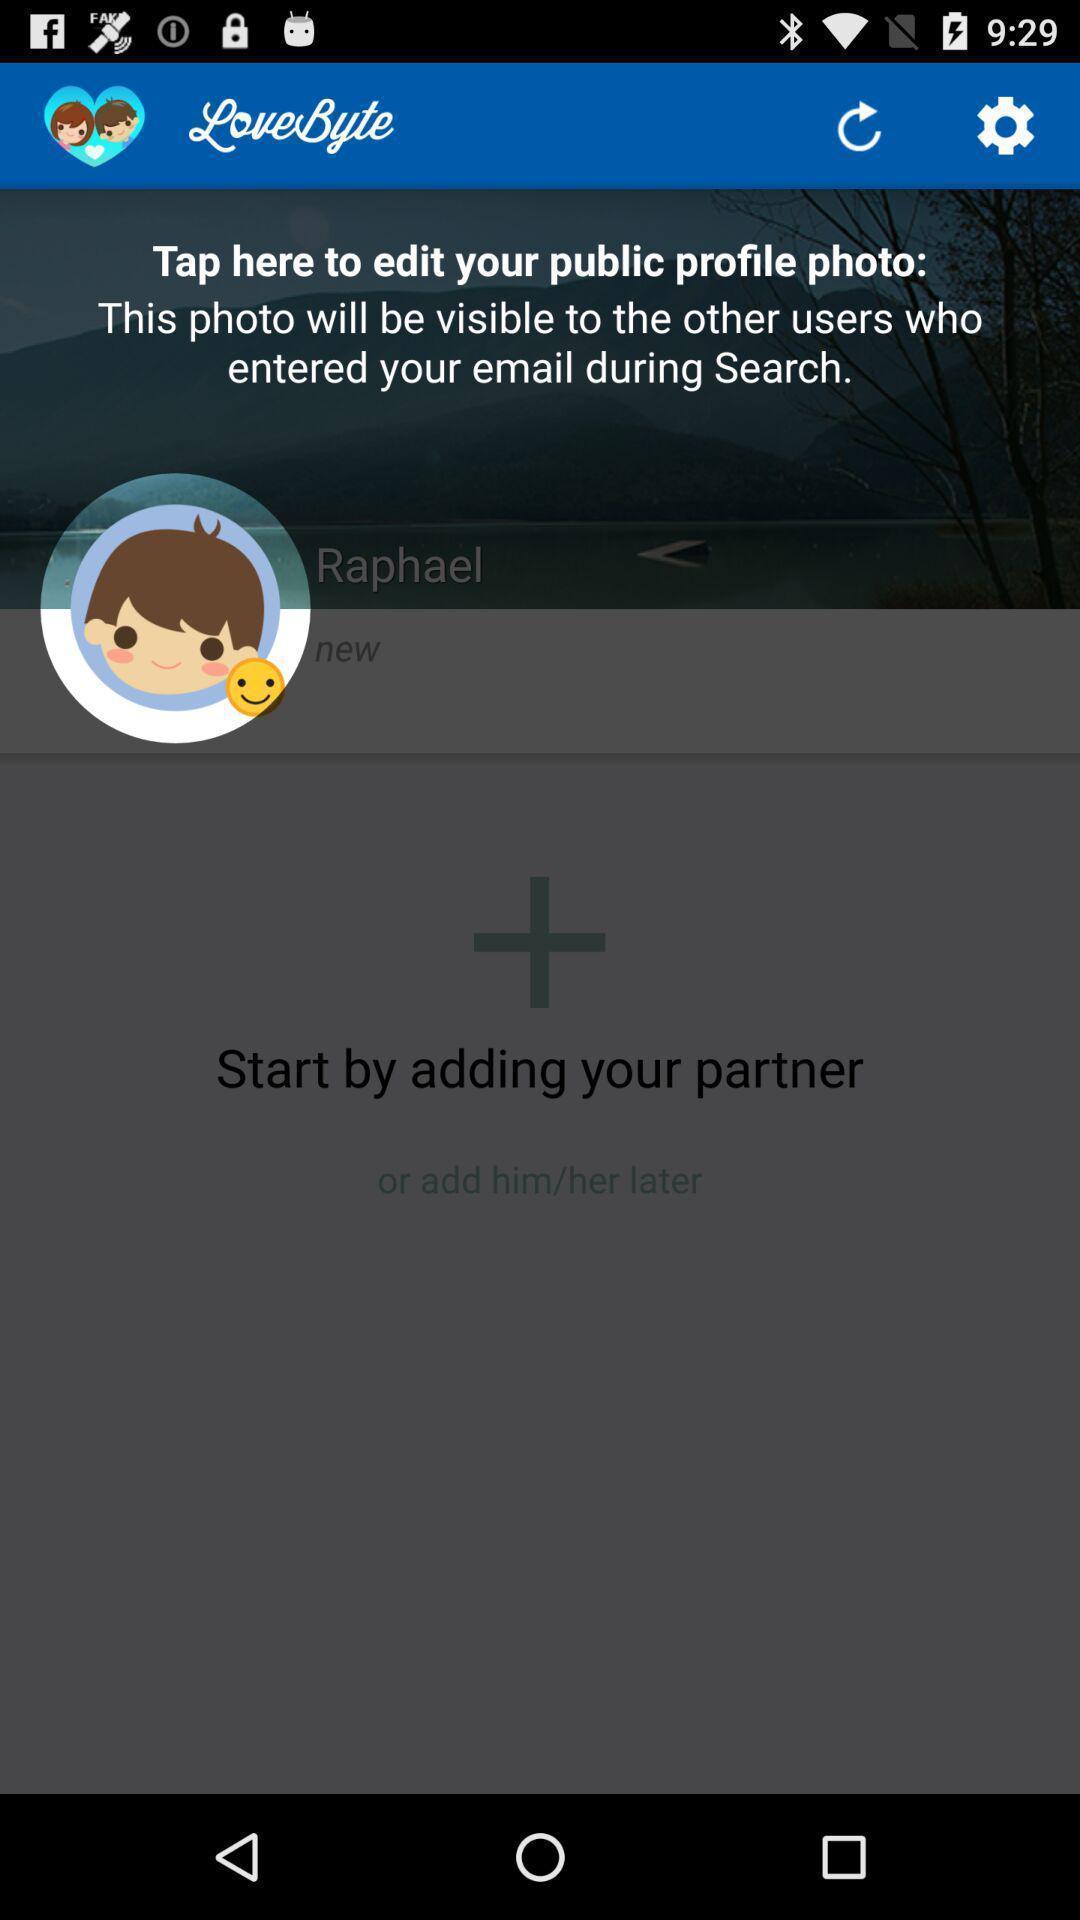Provide a textual representation of this image. Popup of the edit option on your profile. 